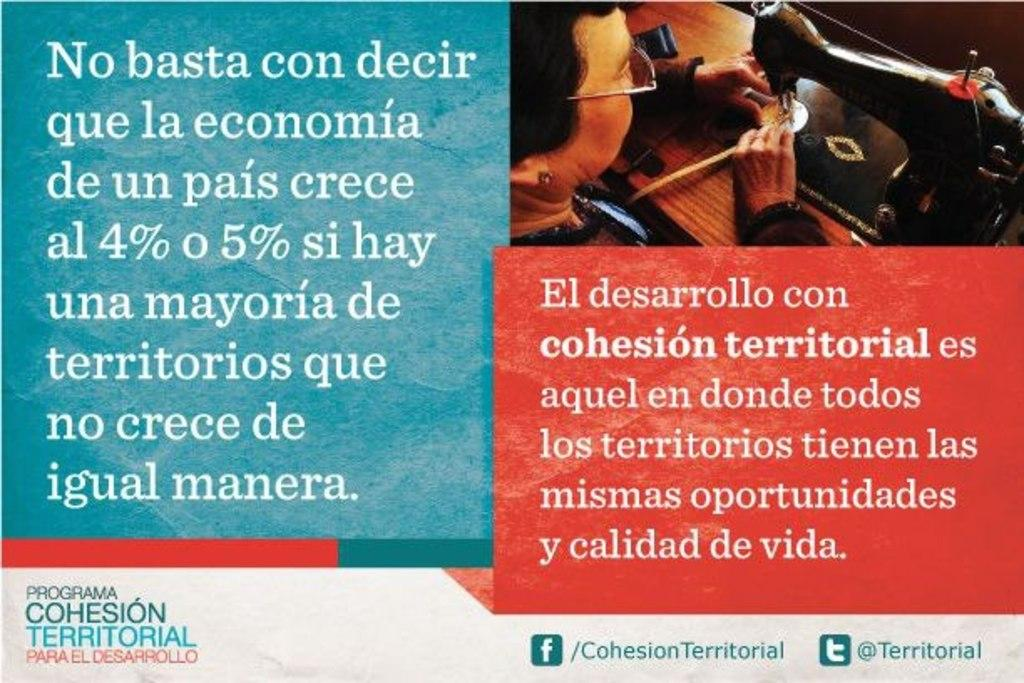What is the main subject of the image? The main subject of the image is an advertisement. What is featured in the advertisement? The advertisement contains a picture of a sewing machine and a picture of a woman. What type of story is the kitten telling in the image? There is no kitten present in the image, so it cannot be telling any story. 